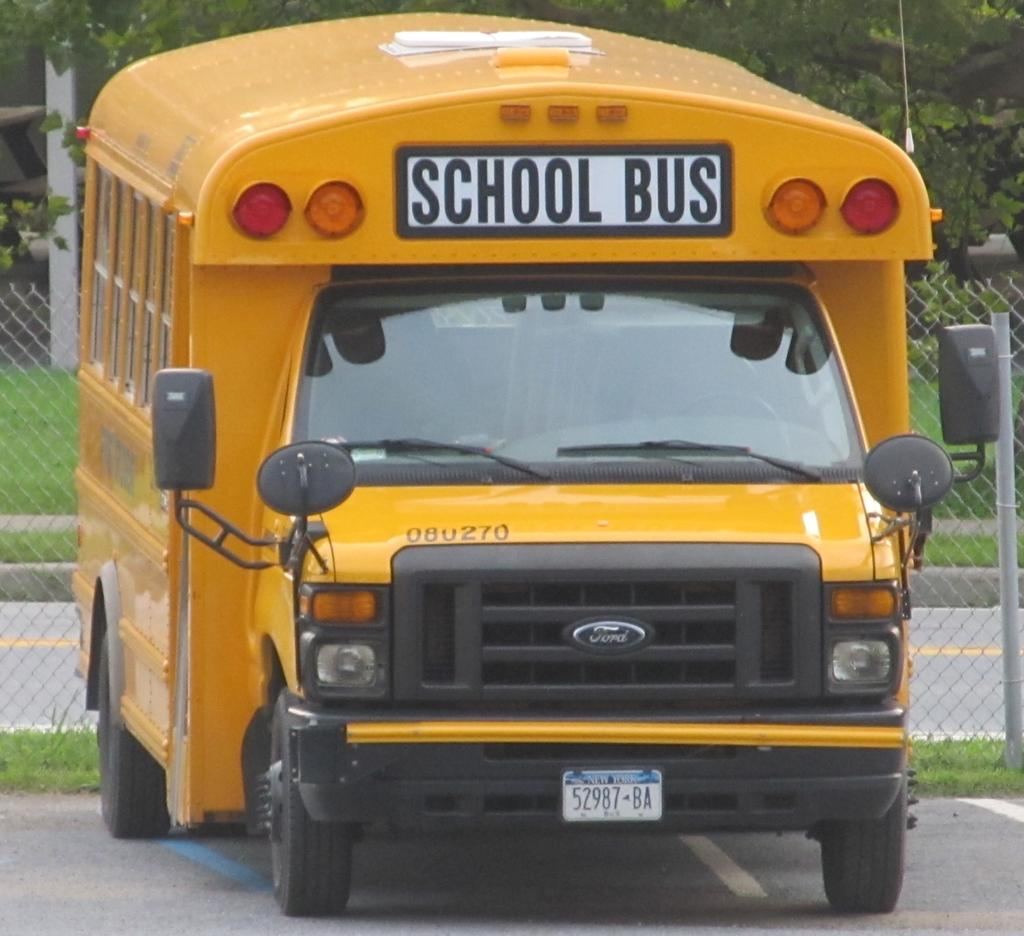<image>
Share a concise interpretation of the image provided. A yellow bus is parked by a fence and it says School Bus on the top front of the vehicle. 